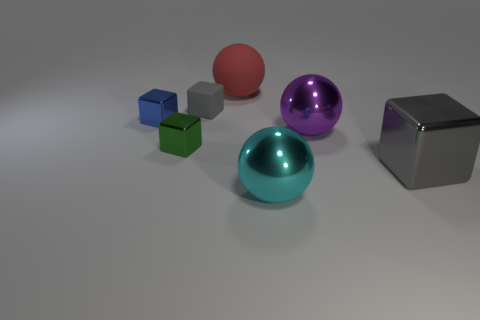There is a large metallic thing that is the same shape as the tiny gray matte thing; what is its color?
Offer a terse response. Gray. Are there fewer tiny green shiny cubes that are in front of the tiny blue metallic block than tiny blue shiny objects?
Your answer should be very brief. No. There is a big thing that is the same color as the small matte block; what is its material?
Give a very brief answer. Metal. Is the tiny gray thing made of the same material as the purple ball?
Keep it short and to the point. No. How many other things are made of the same material as the big purple thing?
Your answer should be compact. 4. The large block that is the same material as the big cyan thing is what color?
Provide a short and direct response. Gray. What is the shape of the small rubber object?
Make the answer very short. Cube. What is the material of the gray block that is right of the large red sphere?
Offer a very short reply. Metal. Is there a large matte sphere that has the same color as the big metal block?
Give a very brief answer. No. There is a cyan shiny thing that is the same size as the purple metal object; what is its shape?
Ensure brevity in your answer.  Sphere. 